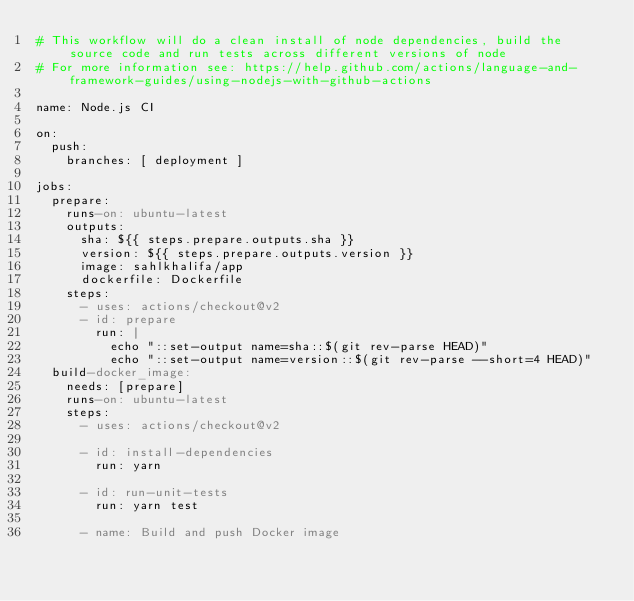Convert code to text. <code><loc_0><loc_0><loc_500><loc_500><_YAML_># This workflow will do a clean install of node dependencies, build the source code and run tests across different versions of node
# For more information see: https://help.github.com/actions/language-and-framework-guides/using-nodejs-with-github-actions

name: Node.js CI

on:
  push:
    branches: [ deployment ]

jobs:
  prepare:
    runs-on: ubuntu-latest
    outputs:
      sha: ${{ steps.prepare.outputs.sha }}
      version: ${{ steps.prepare.outputs.version }}
      image: sahlkhalifa/app
      dockerfile: Dockerfile
    steps:
      - uses: actions/checkout@v2
      - id: prepare
        run: |
          echo "::set-output name=sha::$(git rev-parse HEAD)"
          echo "::set-output name=version::$(git rev-parse --short=4 HEAD)"
  build-docker_image:
    needs: [prepare]
    runs-on: ubuntu-latest
    steps:
      - uses: actions/checkout@v2
      
      - id: install-dependencies
        run: yarn

      - id: run-unit-tests
        run: yarn test
      
      - name: Build and push Docker image</code> 